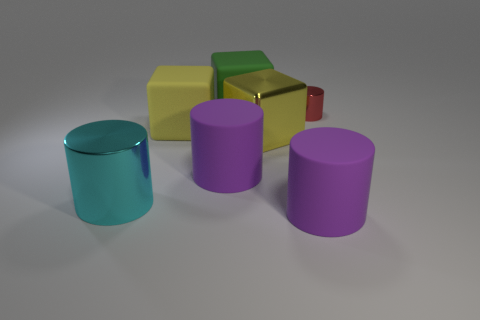Add 2 large rubber cubes. How many objects exist? 9 Subtract all cylinders. How many objects are left? 3 Add 3 red cylinders. How many red cylinders are left? 4 Add 5 big blocks. How many big blocks exist? 8 Subtract 0 yellow spheres. How many objects are left? 7 Subtract all brown shiny cylinders. Subtract all large yellow matte blocks. How many objects are left? 6 